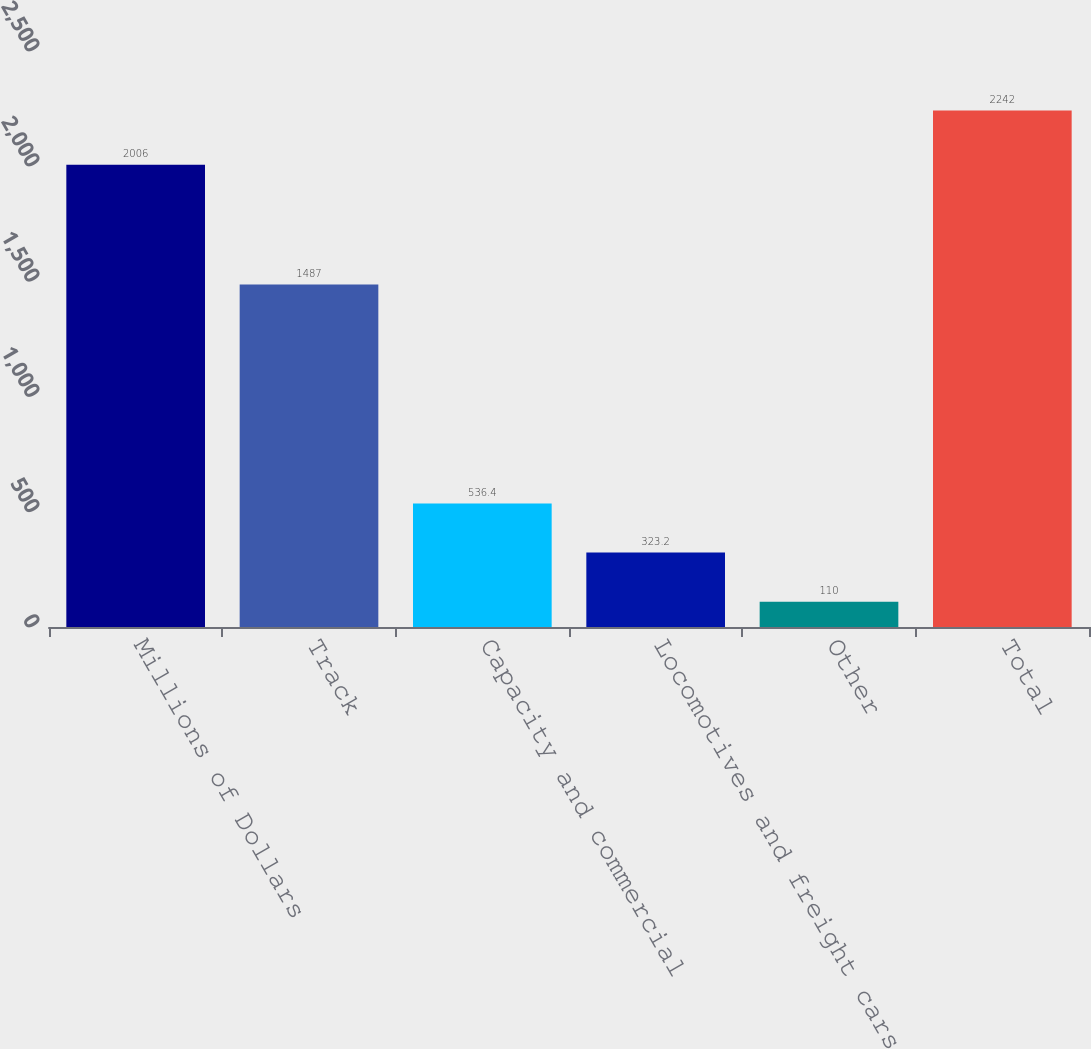<chart> <loc_0><loc_0><loc_500><loc_500><bar_chart><fcel>Millions of Dollars<fcel>Track<fcel>Capacity and commercial<fcel>Locomotives and freight cars<fcel>Other<fcel>Total<nl><fcel>2006<fcel>1487<fcel>536.4<fcel>323.2<fcel>110<fcel>2242<nl></chart> 